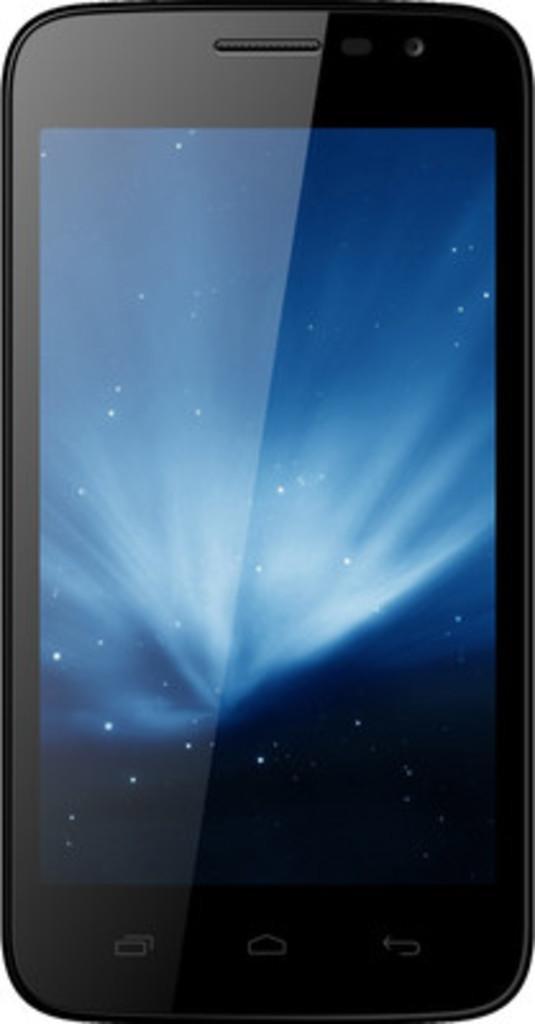Can you describe this image briefly? In this image, we can see a mobile phone and the background is white in color. 